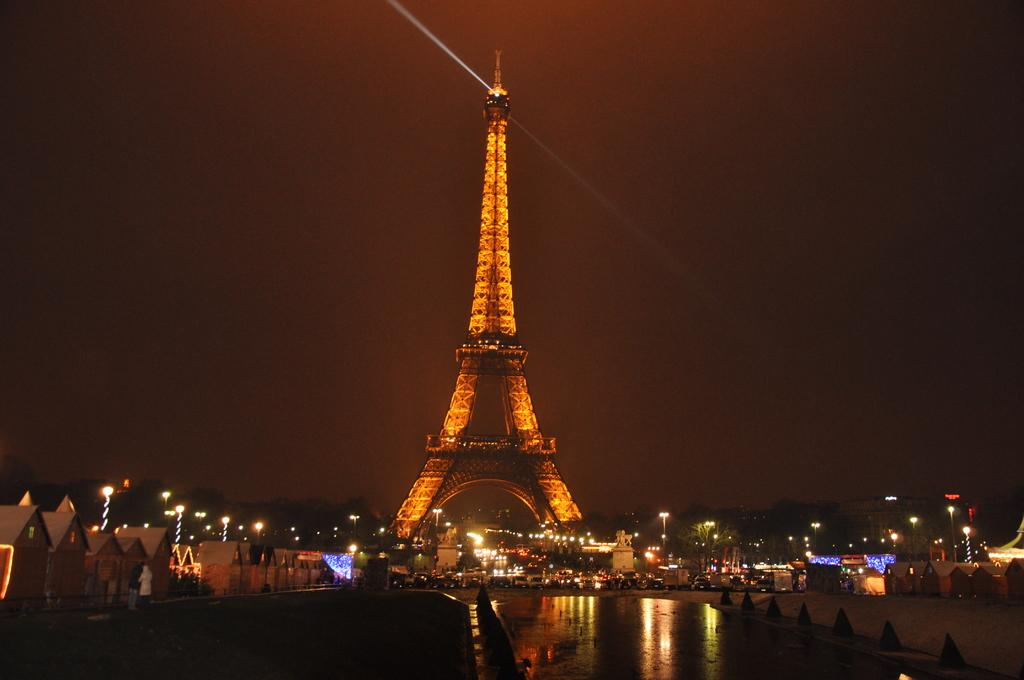What famous landmark can be seen in the image? The Eiffel tower is visible in the image. What type of structures are present in the image besides the Eiffel tower? There are houses in the image. What are the poles used for in the image? The purpose of the poles is not specified, but they are likely used for support or signage. What can be seen illuminated in the image? There are lights in the image. What type of natural elements are present in the image? There are trees and water visible in the image. What type of signage is present in the image? There are boards with text in the image. What is visible in the background of the image? The sky is visible in the background of the image. What type of drum can be heard playing in the image? There is no drum present or audible in the image. 